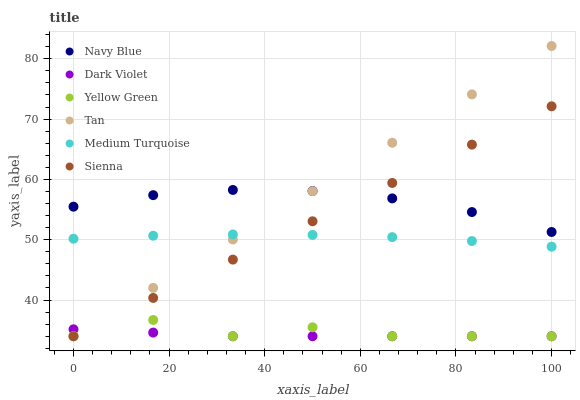Does Dark Violet have the minimum area under the curve?
Answer yes or no. Yes. Does Tan have the maximum area under the curve?
Answer yes or no. Yes. Does Navy Blue have the minimum area under the curve?
Answer yes or no. No. Does Navy Blue have the maximum area under the curve?
Answer yes or no. No. Is Sienna the smoothest?
Answer yes or no. Yes. Is Yellow Green the roughest?
Answer yes or no. Yes. Is Navy Blue the smoothest?
Answer yes or no. No. Is Navy Blue the roughest?
Answer yes or no. No. Does Yellow Green have the lowest value?
Answer yes or no. Yes. Does Navy Blue have the lowest value?
Answer yes or no. No. Does Tan have the highest value?
Answer yes or no. Yes. Does Navy Blue have the highest value?
Answer yes or no. No. Is Dark Violet less than Navy Blue?
Answer yes or no. Yes. Is Navy Blue greater than Dark Violet?
Answer yes or no. Yes. Does Dark Violet intersect Sienna?
Answer yes or no. Yes. Is Dark Violet less than Sienna?
Answer yes or no. No. Is Dark Violet greater than Sienna?
Answer yes or no. No. Does Dark Violet intersect Navy Blue?
Answer yes or no. No. 